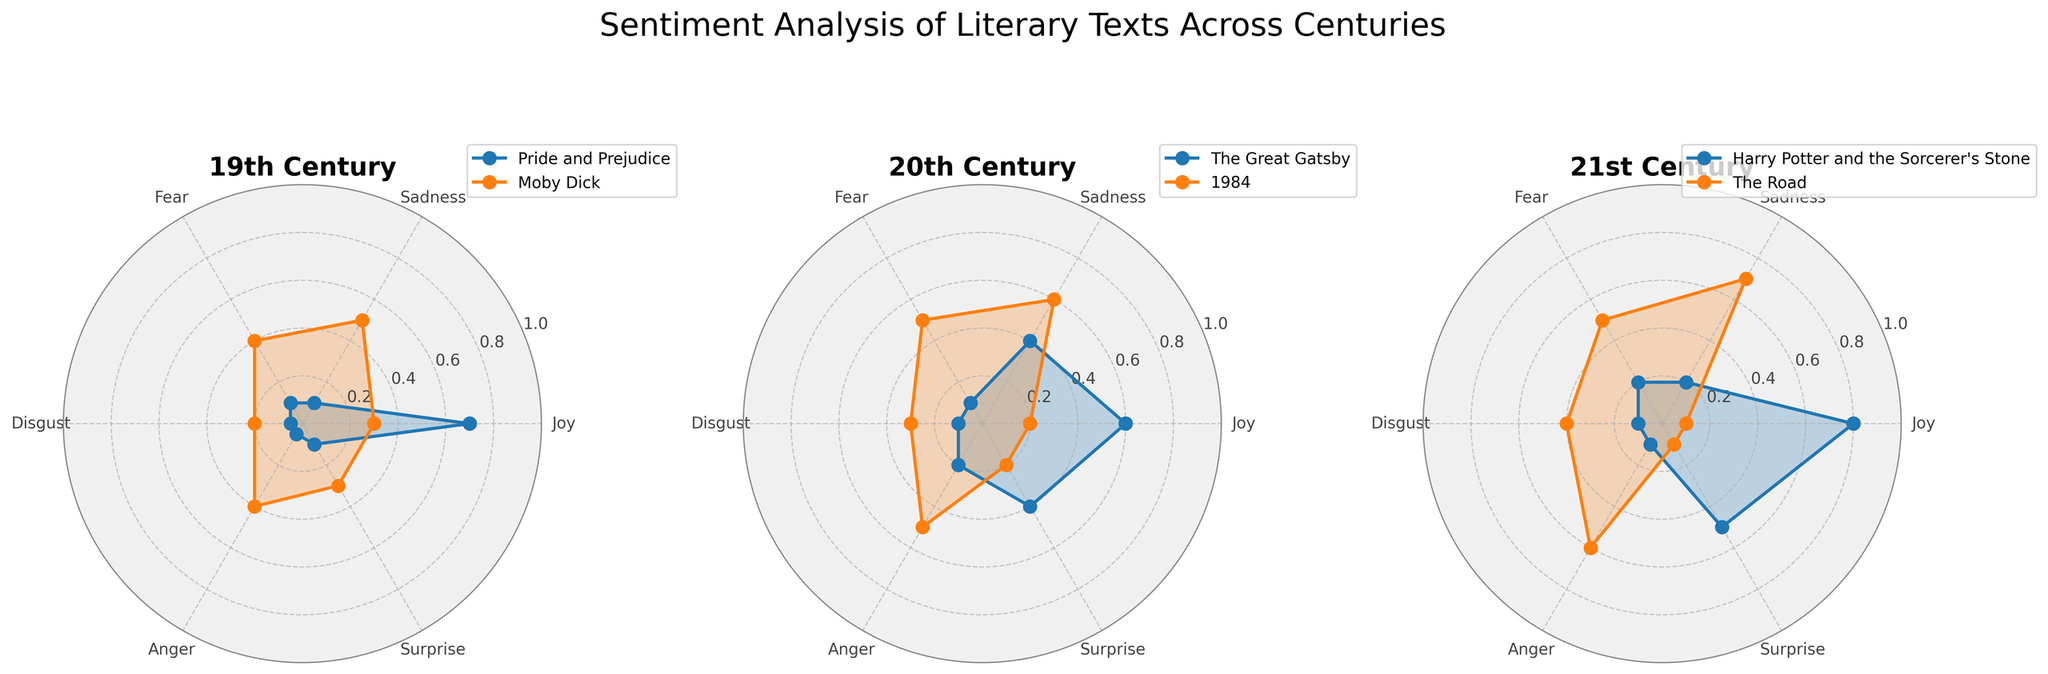What is the title of the figure? The title of the figure is typically presented at the top, and in this figure, it is written above the subplots.
Answer: Sentiment Analysis of Literary Texts Across Centuries Which century's texts show the highest level of Joy? By looking at the levels of Joy on the radar charts, we can see that "Harry Potter and the Sorcerer's Stone" in the 21st century has the highest Joy level at 0.8.
Answer: 21st century Which text in the 19th century has the highest level of Sadness? The two texts in the 19th century are "Pride and Prejudice" and "Moby Dick". By comparing their Sadness levels on the radar chart, "Moby Dick" has a Sadness level of 0.5, which is higher than "Pride and Prejudice" (0.1).
Answer: Moby Dick Arrange the texts from highest to lowest Fear levels. By examining the Fear values on each plot, the levels are: "The Road" (0.5), "1984" (0.5), "Moby Dick" (0.4), "Harry Potter and the Sorcerer's Stone" (0.2), "The Great Gatsby" (0.1), "Pride and Prejudice" (0.1). Arranging them, we get "The Road" and "1984" at the top followed by "Moby Dick", "Harry Potter and the Sorcerer's Stone", "The Great Gatsby", and "Pride and Prejudice" at the bottom.
Answer: "The Road", "1984", "Moby Dick", "Harry Potter and the Sorcerer's Stone", "The Great Gatsby", "Pride and Prejudice" Which century features a text with an equal level of Anger and Fear? By examining the radar charts, "1984" in the 20th century shows equal levels of Anger and Fear, both at 0.5.
Answer: 20th century Compare the Surprise levels between the 19th and 21st century texts. Which century has the text with the highest Surprise level? By looking at the Surprise values on the radar charts for the 19th and 21st centuries, the 21st century's "Harry Potter and the Sorcerer's Stone" has the highest Surprise level at 0.5, compared to all texts in the 19th century.
Answer: 21st century In the 20th century, which emotion is consistently higher in "The Great Gatsby" compared to "1984"? By comparing the radar plots for "The Great Gatsby" and "1984" across all emotions: Joy (0.6 vs 0.2), Sadness (0.4 vs 0.6), Fear (0.1 vs 0.5), Disgust (0.1 vs 0.3), Anger (0.2 vs 0.5), Surprise (0.4 vs 0.2), only the Joy in "The Great Gatsby" is consistently higher compared to "1984".
Answer: Joy Which text has the lowest level of Disgust, and what is its value? By comparing the Disgust levels in the radar charts, "Pride and Prejudice" and "The Great Gatsby" both have the lowest Disgust level with a value of 0.05.
Answer: Pride and Prejudice, 0.05 How does the sentiment distribution for "The Road" compare to "Pride and Prejudice" in terms of Joy and Sadness? On the radar chart, "The Road" has 0.1 for Joy and 0.7 for Sadness, while "Pride and Prejudice" has 0.7 for Joy and 0.1 for Sadness. The distribution is almost completely inverted between Joy and Sadness for these two texts.
Answer: Inverted Joy and Sadness 